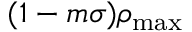Convert formula to latex. <formula><loc_0><loc_0><loc_500><loc_500>( 1 - m \sigma ) \rho _ { \max }</formula> 